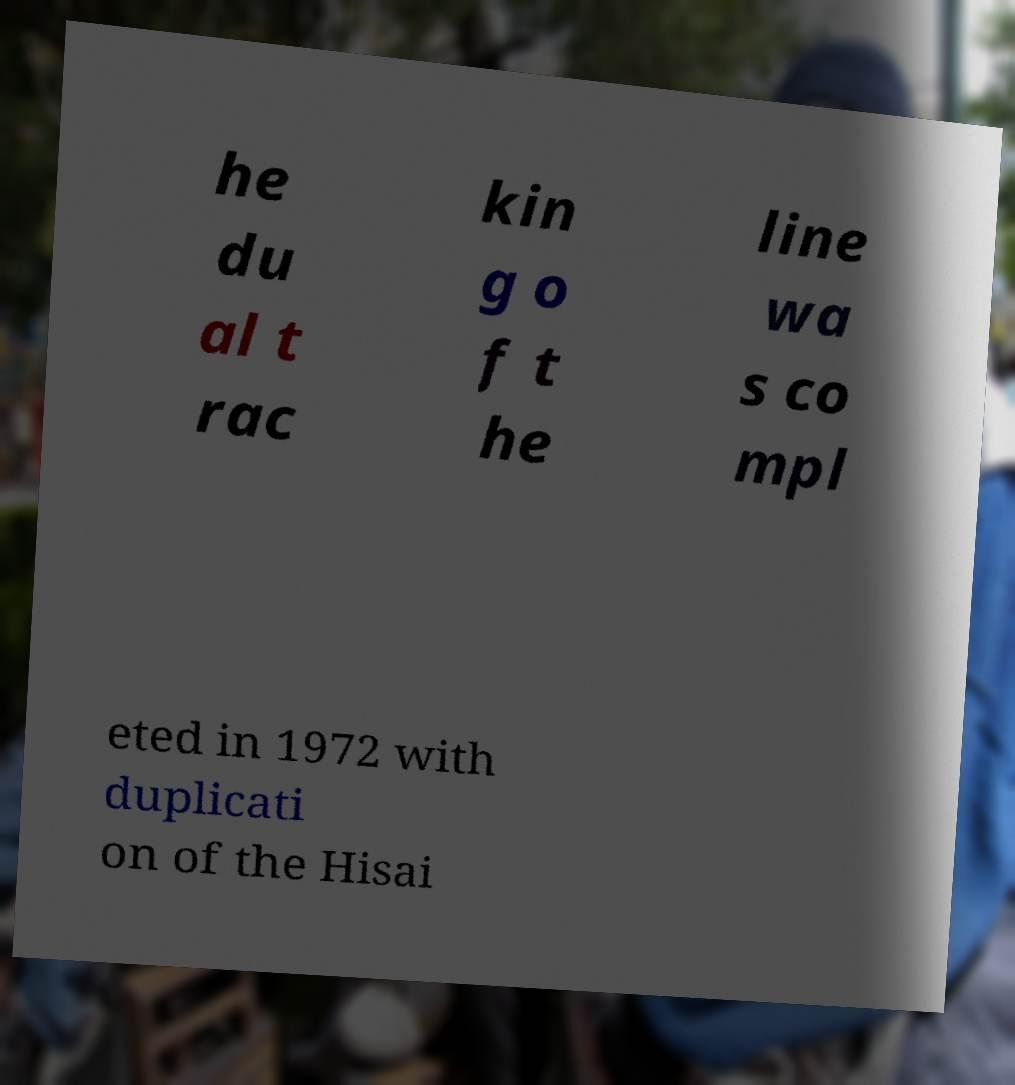Can you read and provide the text displayed in the image?This photo seems to have some interesting text. Can you extract and type it out for me? he du al t rac kin g o f t he line wa s co mpl eted in 1972 with duplicati on of the Hisai 